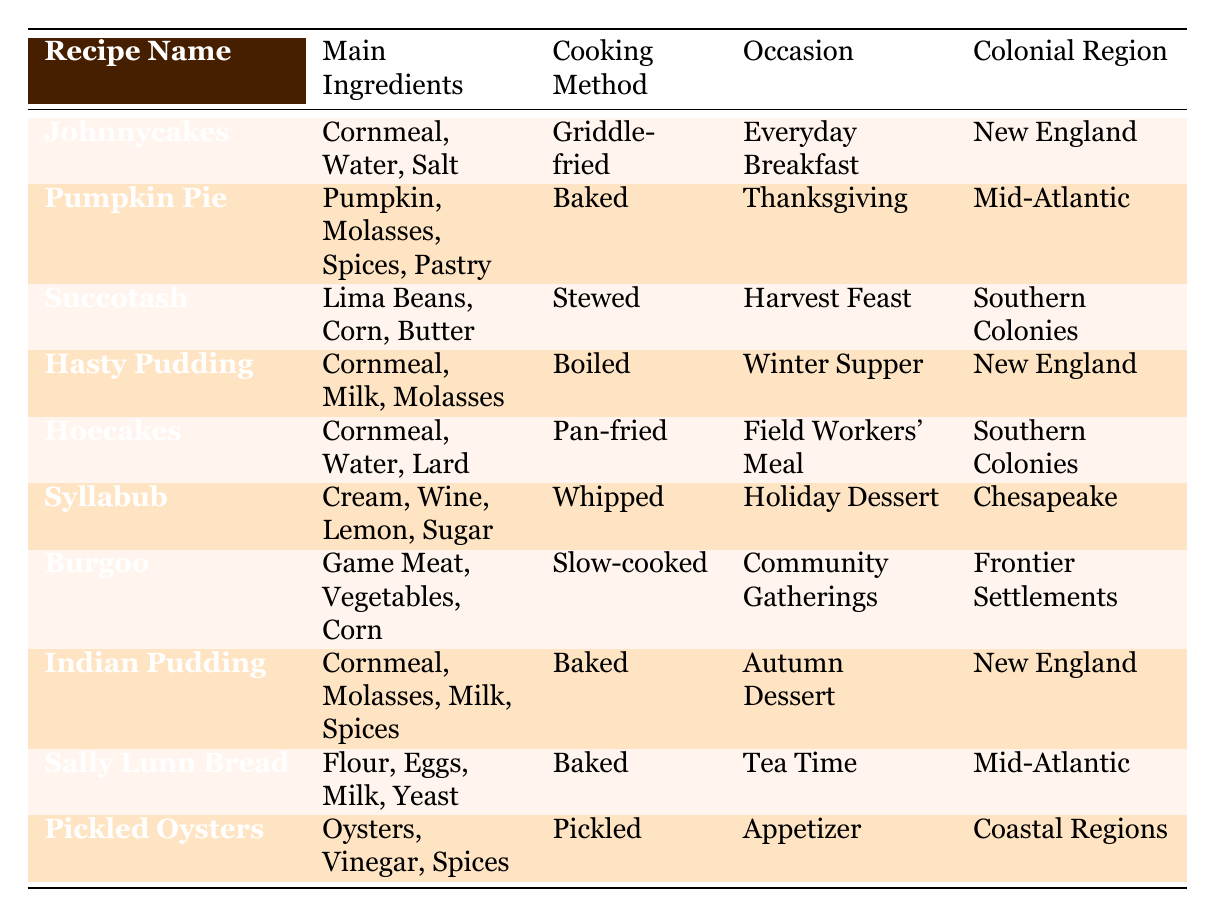What is the main ingredient in Johnnycakes? The table clearly lists Johnnycakes, which has "Cornmeal, Water, Salt" listed under the Main Ingredients column.
Answer: Cornmeal, Water, Salt Which recipe is a holiday dessert? Looking at the Occasion column, Syllabub is marked for "Holiday Dessert," which identifies it as the recipe for this category.
Answer: Syllabub How many recipes are baked? By reviewing the Cooking Method column, we can find that Pumpkin Pie, Indian Pudding, and Sally Lunn Bread are marked as "Baked." Counting these gives us three baked recipes.
Answer: 3 Is Succotash part of New England cuisine? The table specifies that Succotash is from the Southern Colonies as per the Colonial Region column, so this statement is false.
Answer: No Which dish is served at a Winter Supper? The table identifies Hasty Pudding as the dish for a "Winter Supper" in the Occasion column, making it the answer to this question.
Answer: Hasty Pudding Which region has a recipe for an appetizer? If we look closely at the table, Pickled Oysters is noted as an appetizer in the Occasion column, and it belongs to the Coastal Regions, making this region the answer.
Answer: Coastal Regions What is the difference in the cooking methods between Hoecakes and Burgoo? Hoecakes are "Pan-fried," while Burgoo is "Slow-cooked." The difference is that one is a quick cooking method (pan-frying) and the other is slow cooking, indicating a significant variance in preparation time and technique.
Answer: Pan-fried; Slow-cooked Which recipe features Lima Beans as an ingredient? The table states that Succotash includes Lima Beans under the Main Ingredients column, allowing us to identify this particular recipe with Lima Beans.
Answer: Succotash List all recipes that use cornmeal. Examining the Main Ingredients column shows that Johnnycakes, Hasty Pudding, Hoecakes, Indian Pudding, and Succotash all include cornmeal. By aggregating these, we conclude that five recipes utilize cornmeal.
Answer: 5 recipes: Johnnycakes, Hasty Pudding, Hoecakes, Indian Pudding, Succotash 